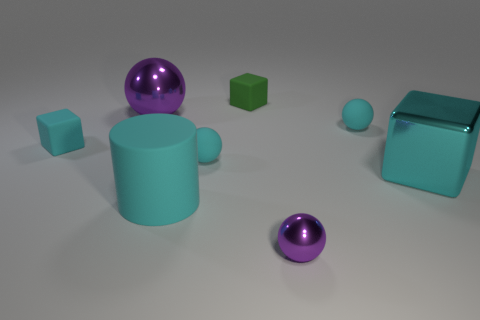Subtract all green balls. Subtract all red cylinders. How many balls are left? 4 Add 2 large cyan metal cubes. How many objects exist? 10 Subtract all blocks. How many objects are left? 5 Subtract all large purple shiny balls. Subtract all tiny matte balls. How many objects are left? 5 Add 2 tiny purple objects. How many tiny purple objects are left? 3 Add 6 big rubber cylinders. How many big rubber cylinders exist? 7 Subtract 0 brown cylinders. How many objects are left? 8 